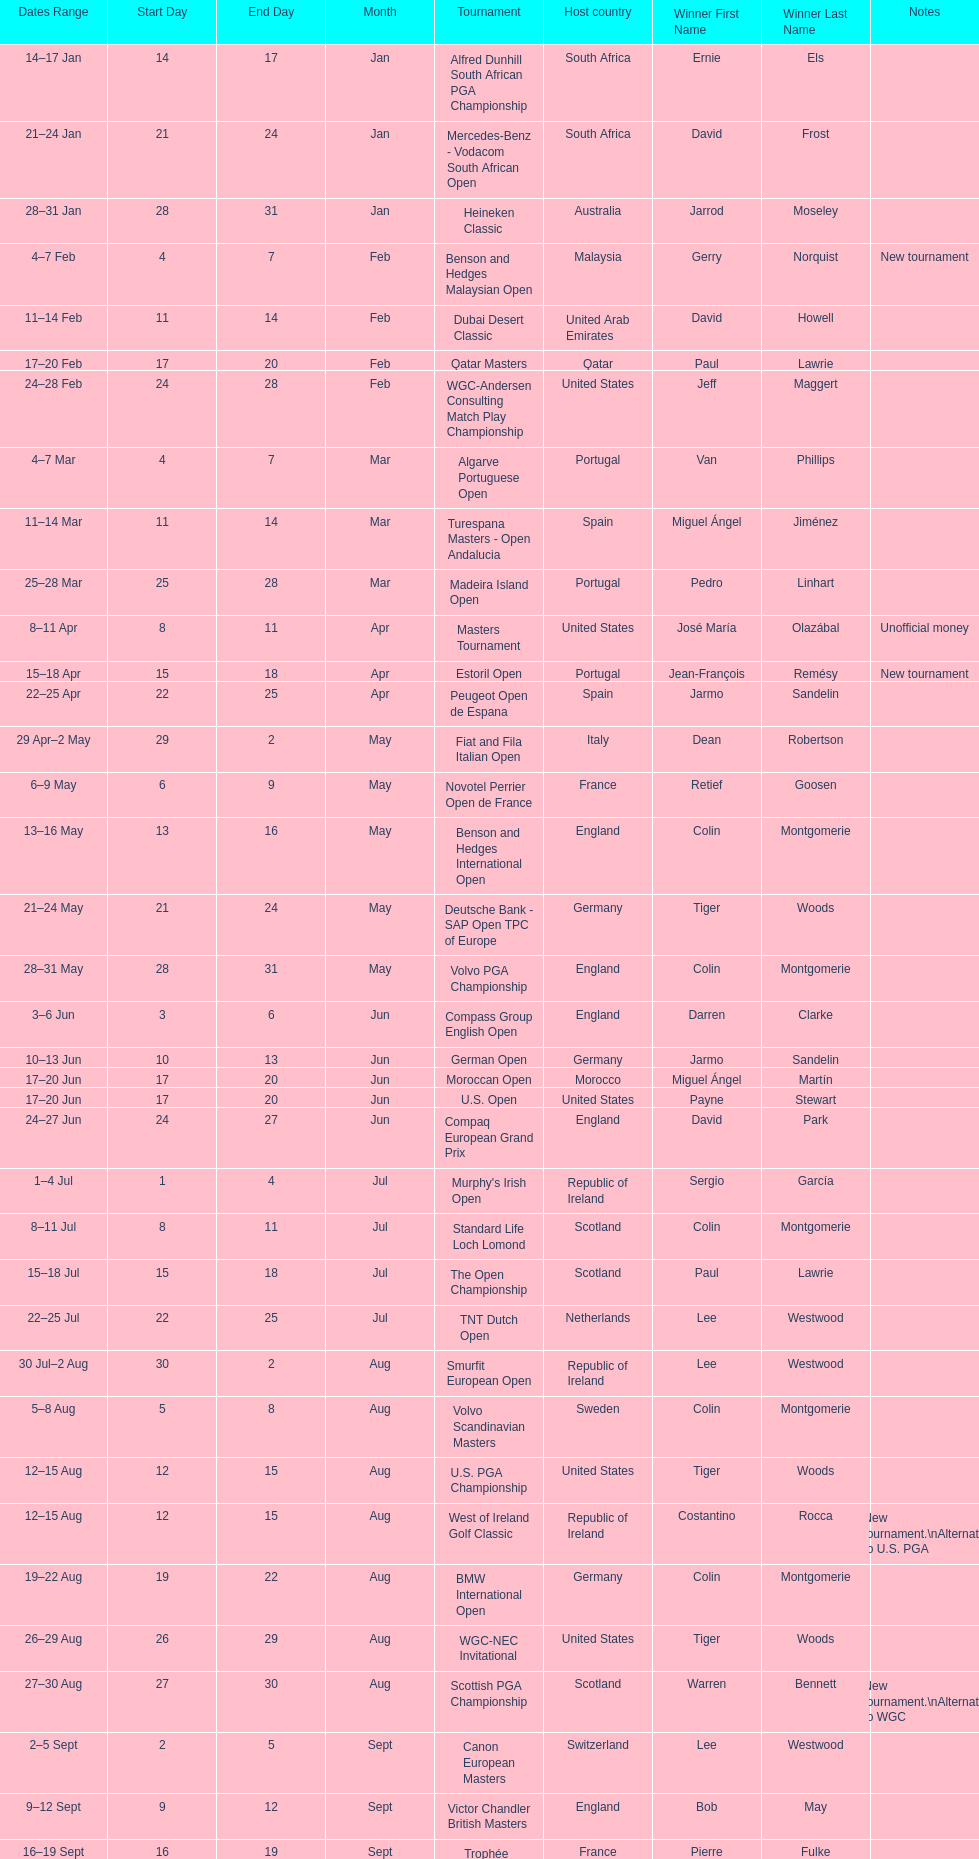How many consecutive times was south africa the host country? 2. Can you parse all the data within this table? {'header': ['Dates Range', 'Start Day', 'End Day', 'Month', 'Tournament', 'Host country', 'Winner First Name', 'Winner Last Name', 'Notes'], 'rows': [['14–17\xa0Jan', '14', '17', 'Jan', 'Alfred Dunhill South African PGA Championship', 'South Africa', 'Ernie', 'Els', ''], ['21–24\xa0Jan', '21', '24', 'Jan', 'Mercedes-Benz - Vodacom South African Open', 'South Africa', 'David', 'Frost', ''], ['28–31\xa0Jan', '28', '31', 'Jan', 'Heineken Classic', 'Australia', 'Jarrod', 'Moseley', ''], ['4–7\xa0Feb', '4', '7', 'Feb', 'Benson and Hedges Malaysian Open', 'Malaysia', 'Gerry', 'Norquist', 'New tournament'], ['11–14\xa0Feb', '11', '14', 'Feb', 'Dubai Desert Classic', 'United Arab Emirates', 'David', 'Howell', ''], ['17–20\xa0Feb', '17', '20', 'Feb', 'Qatar Masters', 'Qatar', 'Paul', 'Lawrie', ''], ['24–28\xa0Feb', '24', '28', 'Feb', 'WGC-Andersen Consulting Match Play Championship', 'United States', 'Jeff', 'Maggert', ''], ['4–7\xa0Mar', '4', '7', 'Mar', 'Algarve Portuguese Open', 'Portugal', 'Van', 'Phillips', ''], ['11–14\xa0Mar', '11', '14', 'Mar', 'Turespana Masters - Open Andalucia', 'Spain', 'Miguel Ángel', 'Jiménez', ''], ['25–28\xa0Mar', '25', '28', 'Mar', 'Madeira Island Open', 'Portugal', 'Pedro', 'Linhart', ''], ['8–11\xa0Apr', '8', '11', 'Apr', 'Masters Tournament', 'United States', 'José María', 'Olazábal', 'Unofficial money'], ['15–18\xa0Apr', '15', '18', 'Apr', 'Estoril Open', 'Portugal', 'Jean-François', 'Remésy', 'New tournament'], ['22–25\xa0Apr', '22', '25', 'Apr', 'Peugeot Open de Espana', 'Spain', 'Jarmo', 'Sandelin', ''], ['29\xa0Apr–2\xa0May', '29', '2', 'May', 'Fiat and Fila Italian Open', 'Italy', 'Dean', 'Robertson', ''], ['6–9\xa0May', '6', '9', 'May', 'Novotel Perrier Open de France', 'France', 'Retief', 'Goosen', ''], ['13–16\xa0May', '13', '16', 'May', 'Benson and Hedges International Open', 'England', 'Colin', 'Montgomerie', ''], ['21–24\xa0May', '21', '24', 'May', 'Deutsche Bank - SAP Open TPC of Europe', 'Germany', 'Tiger', 'Woods', ''], ['28–31\xa0May', '28', '31', 'May', 'Volvo PGA Championship', 'England', 'Colin', 'Montgomerie', ''], ['3–6\xa0Jun', '3', '6', 'Jun', 'Compass Group English Open', 'England', 'Darren', 'Clarke', ''], ['10–13\xa0Jun', '10', '13', 'Jun', 'German Open', 'Germany', 'Jarmo', 'Sandelin', ''], ['17–20\xa0Jun', '17', '20', 'Jun', 'Moroccan Open', 'Morocco', 'Miguel Ángel', 'Martín', ''], ['17–20\xa0Jun', '17', '20', 'Jun', 'U.S. Open', 'United States', 'Payne', 'Stewart', ''], ['24–27\xa0Jun', '24', '27', 'Jun', 'Compaq European Grand Prix', 'England', 'David', 'Park', ''], ['1–4\xa0Jul', '1', '4', 'Jul', "Murphy's Irish Open", 'Republic of Ireland', 'Sergio', 'García', ''], ['8–11\xa0Jul', '8', '11', 'Jul', 'Standard Life Loch Lomond', 'Scotland', 'Colin', 'Montgomerie', ''], ['15–18\xa0Jul', '15', '18', 'Jul', 'The Open Championship', 'Scotland', 'Paul', 'Lawrie', ''], ['22–25\xa0Jul', '22', '25', 'Jul', 'TNT Dutch Open', 'Netherlands', 'Lee', 'Westwood', ''], ['30\xa0Jul–2\xa0Aug', '30', '2', 'Aug', 'Smurfit European Open', 'Republic of Ireland', 'Lee', 'Westwood', ''], ['5–8\xa0Aug', '5', '8', 'Aug', 'Volvo Scandinavian Masters', 'Sweden', 'Colin', 'Montgomerie', ''], ['12–15\xa0Aug', '12', '15', 'Aug', 'U.S. PGA Championship', 'United States', 'Tiger', 'Woods', ''], ['12–15\xa0Aug', '12', '15', 'Aug', 'West of Ireland Golf Classic', 'Republic of Ireland', 'Costantino', 'Rocca', 'New tournament.\\nAlternate to U.S. PGA'], ['19–22\xa0Aug', '19', '22', 'Aug', 'BMW International Open', 'Germany', 'Colin', 'Montgomerie', ''], ['26–29\xa0Aug', '26', '29', 'Aug', 'WGC-NEC Invitational', 'United States', 'Tiger', 'Woods', ''], ['27–30\xa0Aug', '27', '30', 'Aug', 'Scottish PGA Championship', 'Scotland', 'Warren', 'Bennett', 'New tournament.\\nAlternate to WGC'], ['2–5\xa0Sept', '2', '5', 'Sept', 'Canon European Masters', 'Switzerland', 'Lee', 'Westwood', ''], ['9–12\xa0Sept', '9', '12', 'Sept', 'Victor Chandler British Masters', 'England', 'Bob', 'May', ''], ['16–19\xa0Sept', '16', '19', 'Sept', 'Trophée Lancôme', 'France', 'Pierre', 'Fulke', ''], ['24–27\xa0Sept', '24', '27', 'Sept', 'Ryder Cup', 'United States', 'United States', '', 'Team event'], ['30\xa0Sept–3\xa0Oct', '30', '3', 'Oct', 'Linde German Masters', 'Germany', 'Sergio', 'García', ''], ['7–10\xa0Oct', '7', '10', 'Oct', 'Alfred Dunhill Cup', 'Scotland', 'Spain', '', 'Team event.\\nUnofficial money'], ['14–17\xa0Oct', '14', '17', 'Oct', 'Cisco World Match Play Championship', 'England', 'Colin', 'Montgomerie', 'Unofficial money'], ['14–17\xa0Oct', '14', '17', 'Oct', 'Sarazen World Open', 'Spain', 'Thomas', 'Bjørn', 'New tournament'], ['21–24\xa0Oct', '21', '24', 'Oct', 'Belgacom Open', 'Belgium', 'Robert', 'Karlsson', ''], ['28–31\xa0Oct', '28', '31', 'Oct', 'Volvo Masters', 'Spain', 'Miguel Ángel', 'Jiménez', ''], ['4–7\xa0Nov', '4', '7', 'Nov', 'WGC-American Express Championship', 'Spain', 'Tiger', 'Woods', ''], ['18–21\xa0Nov', '18', '21', 'Nov', 'World Cup of Golf', 'Malaysia', 'United States', '', 'Team event.\\nUnofficial money']]} 